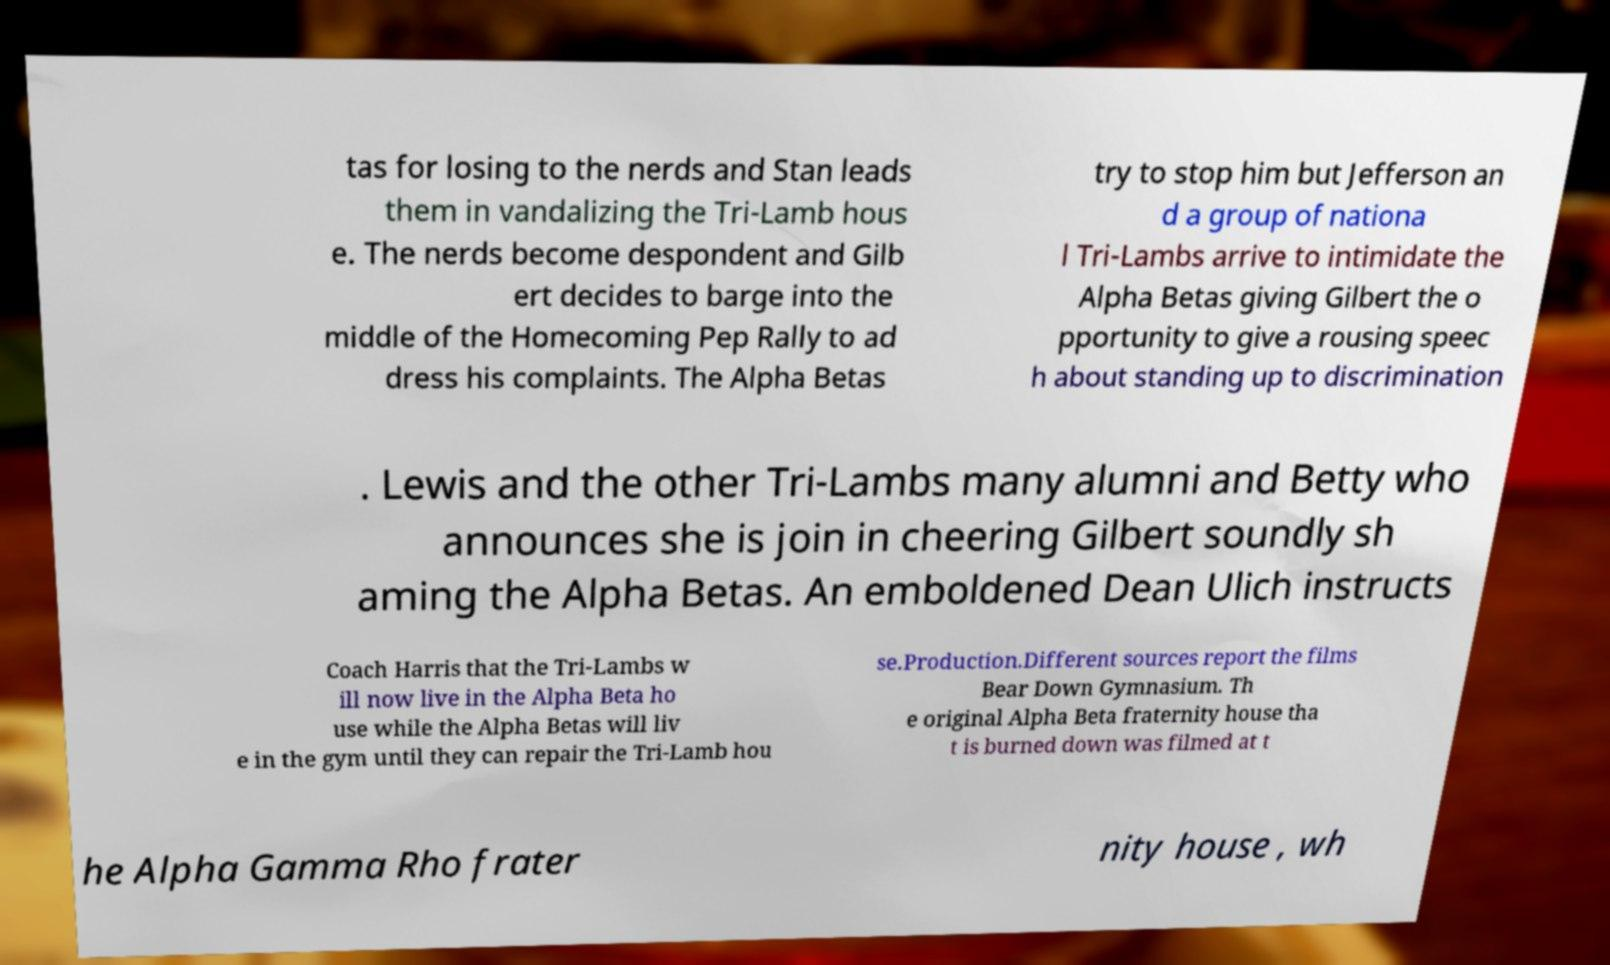Could you extract and type out the text from this image? tas for losing to the nerds and Stan leads them in vandalizing the Tri-Lamb hous e. The nerds become despondent and Gilb ert decides to barge into the middle of the Homecoming Pep Rally to ad dress his complaints. The Alpha Betas try to stop him but Jefferson an d a group of nationa l Tri-Lambs arrive to intimidate the Alpha Betas giving Gilbert the o pportunity to give a rousing speec h about standing up to discrimination . Lewis and the other Tri-Lambs many alumni and Betty who announces she is join in cheering Gilbert soundly sh aming the Alpha Betas. An emboldened Dean Ulich instructs Coach Harris that the Tri-Lambs w ill now live in the Alpha Beta ho use while the Alpha Betas will liv e in the gym until they can repair the Tri-Lamb hou se.Production.Different sources report the films Bear Down Gymnasium. Th e original Alpha Beta fraternity house tha t is burned down was filmed at t he Alpha Gamma Rho frater nity house , wh 